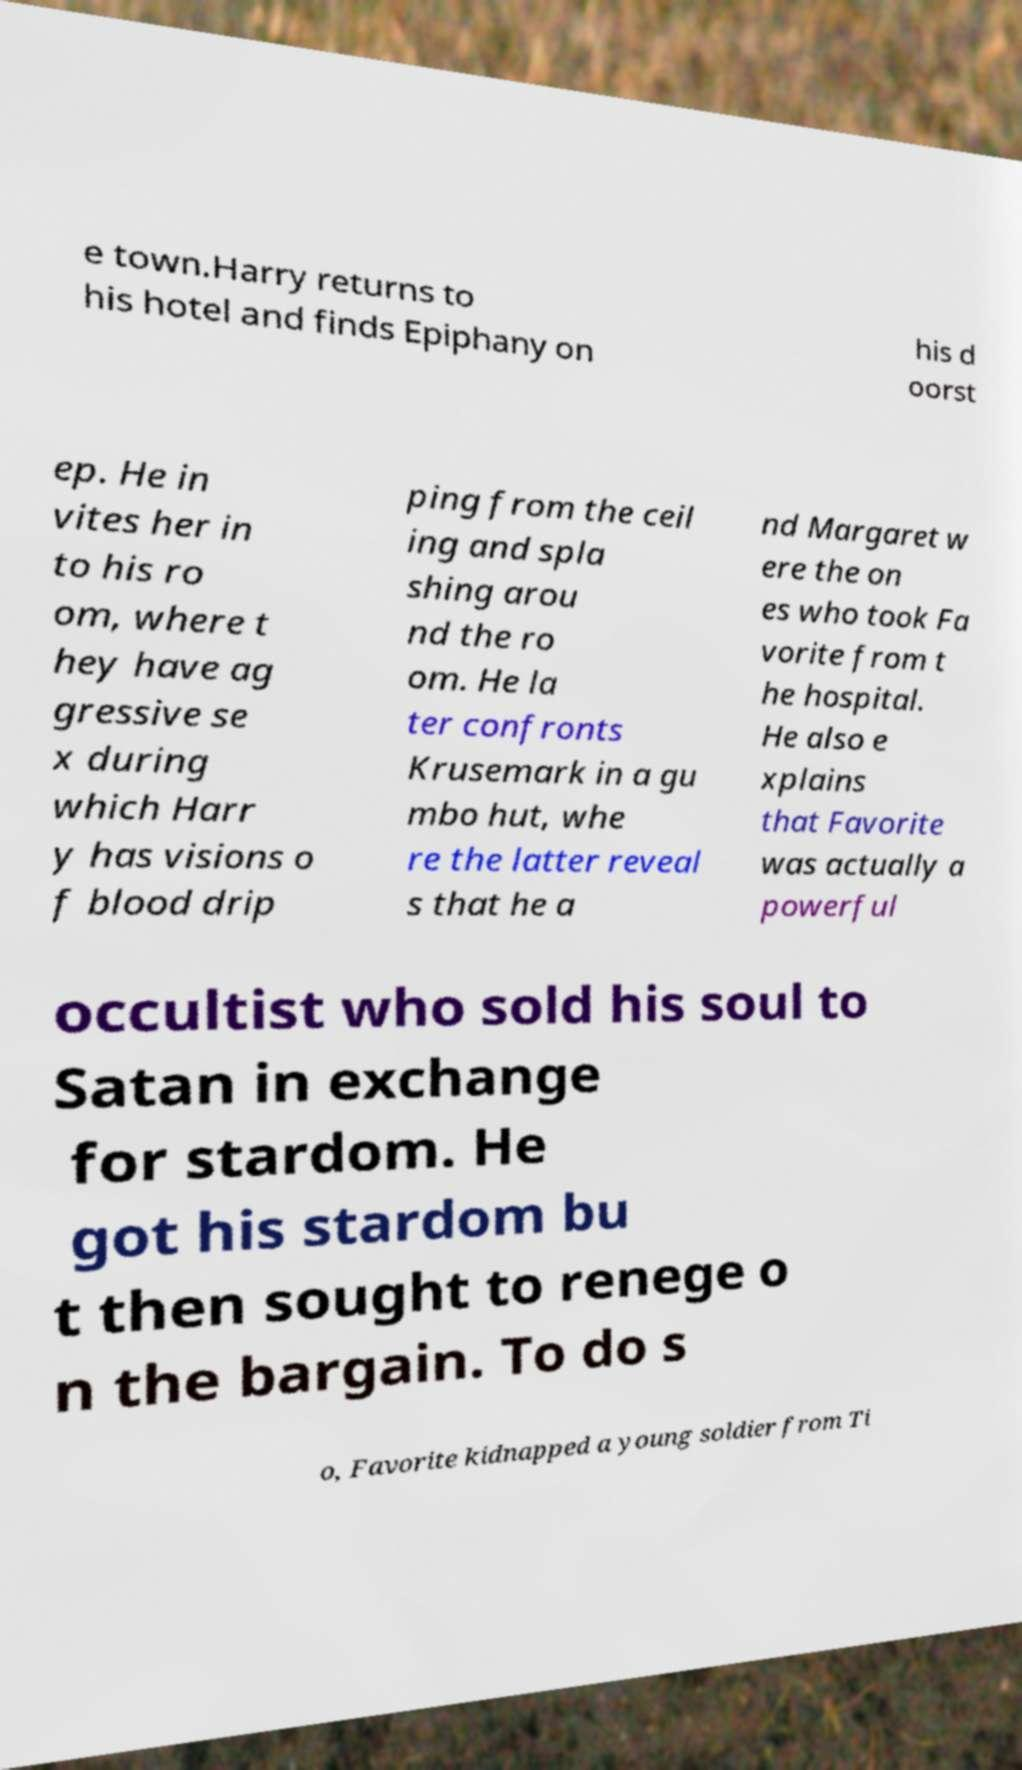Could you extract and type out the text from this image? e town.Harry returns to his hotel and finds Epiphany on his d oorst ep. He in vites her in to his ro om, where t hey have ag gressive se x during which Harr y has visions o f blood drip ping from the ceil ing and spla shing arou nd the ro om. He la ter confronts Krusemark in a gu mbo hut, whe re the latter reveal s that he a nd Margaret w ere the on es who took Fa vorite from t he hospital. He also e xplains that Favorite was actually a powerful occultist who sold his soul to Satan in exchange for stardom. He got his stardom bu t then sought to renege o n the bargain. To do s o, Favorite kidnapped a young soldier from Ti 